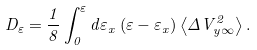Convert formula to latex. <formula><loc_0><loc_0><loc_500><loc_500>D _ { \varepsilon } = \frac { 1 } { 8 } \int _ { 0 } ^ { \varepsilon } d \varepsilon _ { x } \left ( \varepsilon - \varepsilon _ { x } \right ) \left \langle \Delta V _ { y \infty } ^ { 2 } \right \rangle .</formula> 